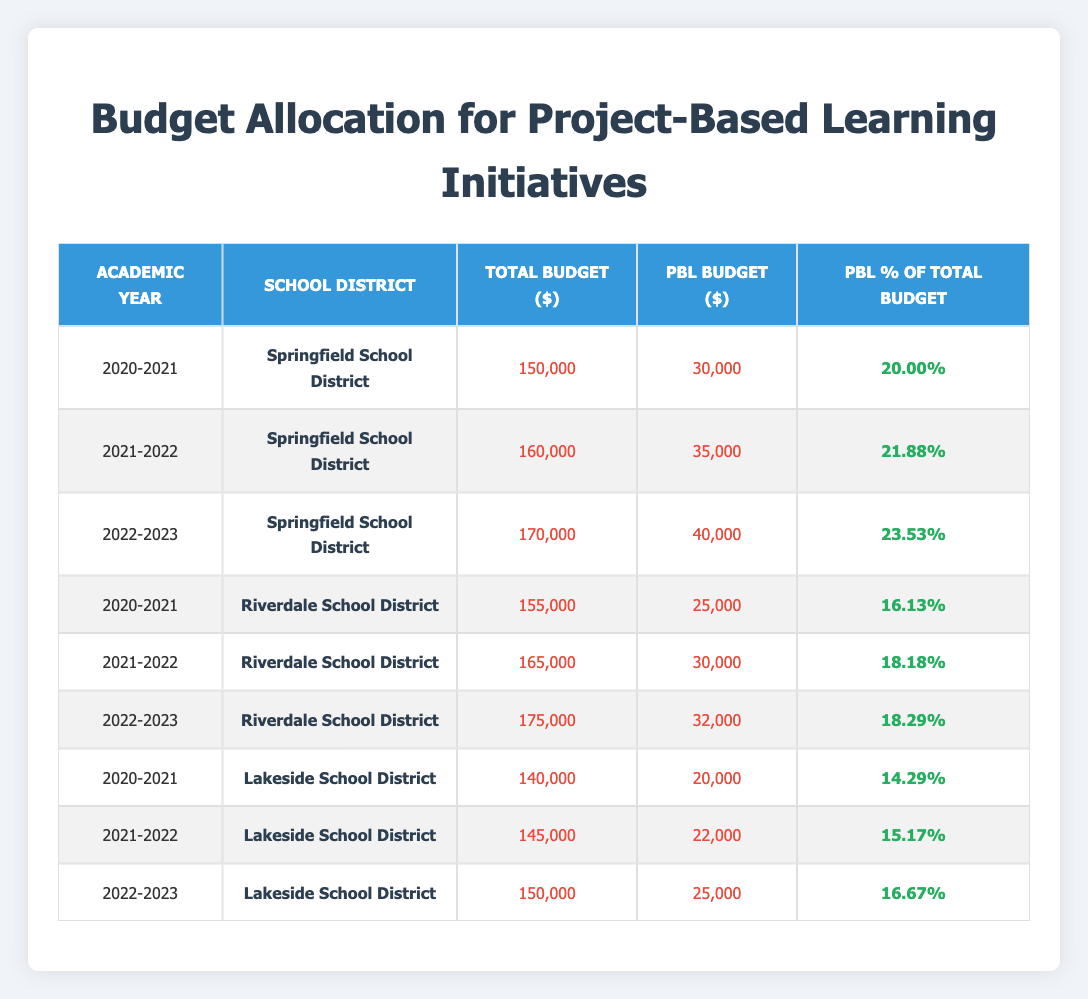What was the total budget for the Springfield School District in the 2021-2022 academic year? Referring to the table, for the Springfield School District in the 2021-2022 academic year, the total budget is listed as 160,000.
Answer: 160,000 Which school district had the highest project-based learning budget in the 2022-2023 academic year? In the 2022-2023 academic year, the Springfield School District had a project-based learning budget of 40,000, which is higher than Riverdale's 32,000 and Lakeside's 25,000, making it the highest.
Answer: Springfield School District What percentage of the total budget was allocated to project-based learning in the Riverdale School District for the 2021-2022 academic year? The percentage of the total budget allocated to project-based learning for Riverdale School District in 2021-2022 is 18.18%, as shown in the percentage column for that academic year.
Answer: 18.18% What was the combined project-based learning budget for all school districts in the 2020-2021 academic year? Adding the project-based learning budgets for all school districts in 2020-2021: Springfield (30,000) + Riverdale (25,000) + Lakeside (20,000) totals 75,000.
Answer: 75,000 Is it true that Lakeside School District allocated more budget to project-based learning in 2021-2022 than in 2020-2021? Yes, Lakeside School District allocated 22,000 in 2021-2022, which is greater than the 20,000 allocated in 2020-2021.
Answer: Yes Which academic year saw the largest increase in the project-based learning budget for the Springfield School District? Comparing the project-based learning budgets for Springfield: 30,000 in 2020-2021, 35,000 in 2021-2022 (increase of 5,000), and 40,000 in 2022-2023 (increase of 5,000). Both subsequent years had equal increases, making it unclear without additional context. However, both resulted in the same increase.
Answer: 2021-2022 and 2022-2023 What was the average percentage of the total budget allocated to project-based learning across all school districts for the 2022-2023 academic year? Calculating the average for the 2022-2023 academic year: Springfield (23.53) + Riverdale (18.29) + Lakeside (16.67) = 58.49. Dividing by 3 gives an average of approximately 19.50.
Answer: 19.50 